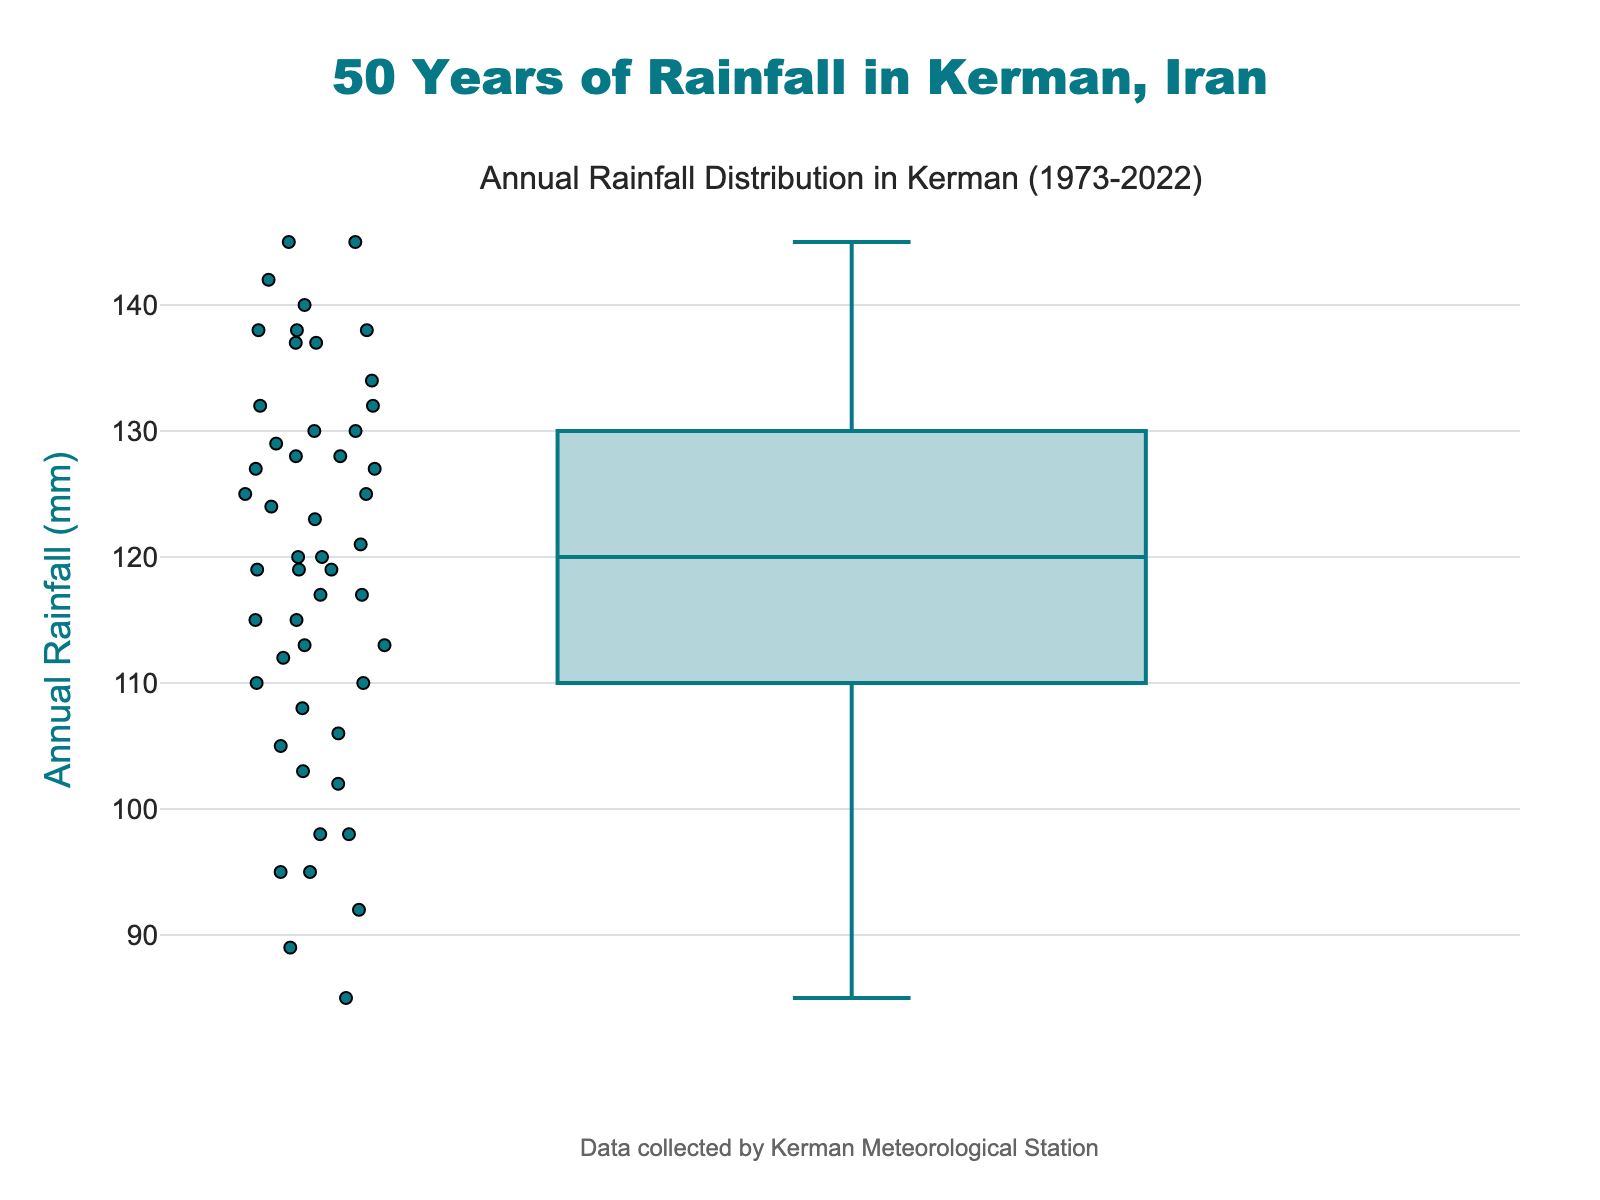What is the title of the figure? The title is prominently displayed at the top of the figure, indicating the focus of the data.
Answer: 50 Years of Rainfall in Kerman, Iran What is the minimum value of annual rainfall recorded? To find the minimum value, look at the bottom of the whisker in the box plot, which represents the lowest data point within 1.5 IQR of the lower quartile.
Answer: 85 mm What is the median annual rainfall over the past 50 years? The median is represented by the line inside the box in the box plot.
Answer: 120 mm Which year had the highest annual rainfall, and what was the value? The highest value is shown by the topmost data point that deviates from the whisker. Upon examining the dataset, this value corresponds to the year 1997.
Answer: 145 mm in 1997 What is the interquartile range (IQR) of annual rainfall? The IQR is the difference between the third quartile (Q3) and the first quartile (Q1). Identify these quartiles in the box plot, with Q3 near the top of the box and Q1 near the bottom.
Answer: 30 mm (from Q1 ≈ 110 mm to Q3 ≈ 140 mm) What can be said about the spread of the annual rainfall data? By examining the entire range and the IQR, one can describe the spread of the data. The box plot shows a wide range and a notable spread between Q1 and Q3.
Answer: The data is spread out with the bulk between 110 mm and 140 mm How would you describe any outliers in the data? Outliers in a box plot are points that lie outside the whiskers. Identify any points beyond the top or bottom whiskers to find the outliers.
Answer: There are no significant outliers in this dataset What does the position of the median within the box indicate? The position of the median inside the box can give insights into the skewness of the data. If the median is closer to the bottom or top of the box, it indicates skewness.
Answer: The median is near the center, suggesting a relatively symmetrical distribution Compare the value range between the 1st quartile and the minimum to the value range between the 3rd quartile and the maximum. Measure the distances from Q1 to the minimum and from Q3 to the maximum by looking at their respective positions on the plot.
Answer: The range from Q1 to the minimum (25 mm) is less than the range from Q3 to the maximum (5 mm) What does the color and style of the box plot indicate about the data? The color and style of the box plot often convey uniformity and emphasis on the key statistics like quartiles, median, and whiskers. This plot uses a calm color scheme to present the data clearly.
Answer: The data is clearly presented, with a consistent color and emphasizing the main statistical aspects 